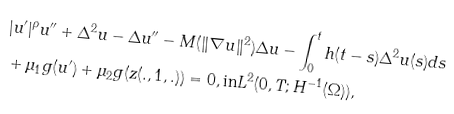Convert formula to latex. <formula><loc_0><loc_0><loc_500><loc_500>& | u ^ { \prime } | ^ { \rho } u ^ { \prime \prime } + \Delta ^ { 2 } u - \Delta u ^ { \prime \prime } - M ( \| \nabla u \| ^ { 2 } ) \Delta u - \int _ { 0 } ^ { t } h ( t - s ) \Delta ^ { 2 } u ( s ) d s \\ & + \mu _ { 1 } g ( u ^ { \prime } ) + \mu _ { 2 } g ( z ( . , 1 , . ) ) = 0 , \text {in} L ^ { 2 } ( 0 , T ; H ^ { - 1 } ( \Omega ) ) ,</formula> 